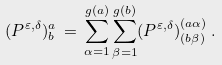Convert formula to latex. <formula><loc_0><loc_0><loc_500><loc_500>( P ^ { \varepsilon , \delta } ) ^ { a } _ { b } \, = \, \sum _ { \alpha = 1 } ^ { g ( a ) } \sum _ { \beta = 1 } ^ { g ( b ) } ( P ^ { \varepsilon , \delta } ) ^ { ( a \alpha ) } _ { ( b \beta ) } \, .</formula> 